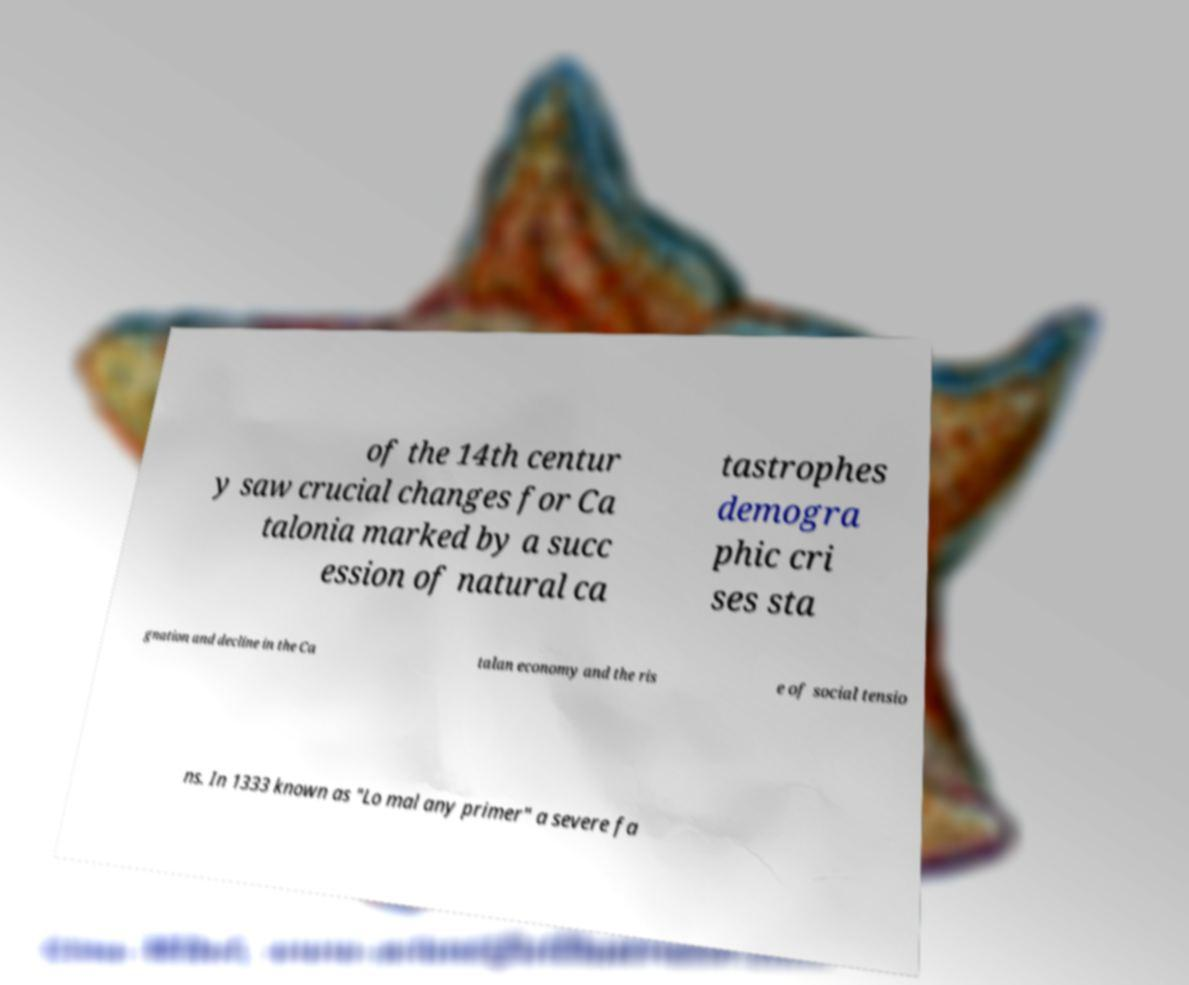What messages or text are displayed in this image? I need them in a readable, typed format. of the 14th centur y saw crucial changes for Ca talonia marked by a succ ession of natural ca tastrophes demogra phic cri ses sta gnation and decline in the Ca talan economy and the ris e of social tensio ns. In 1333 known as "Lo mal any primer" a severe fa 